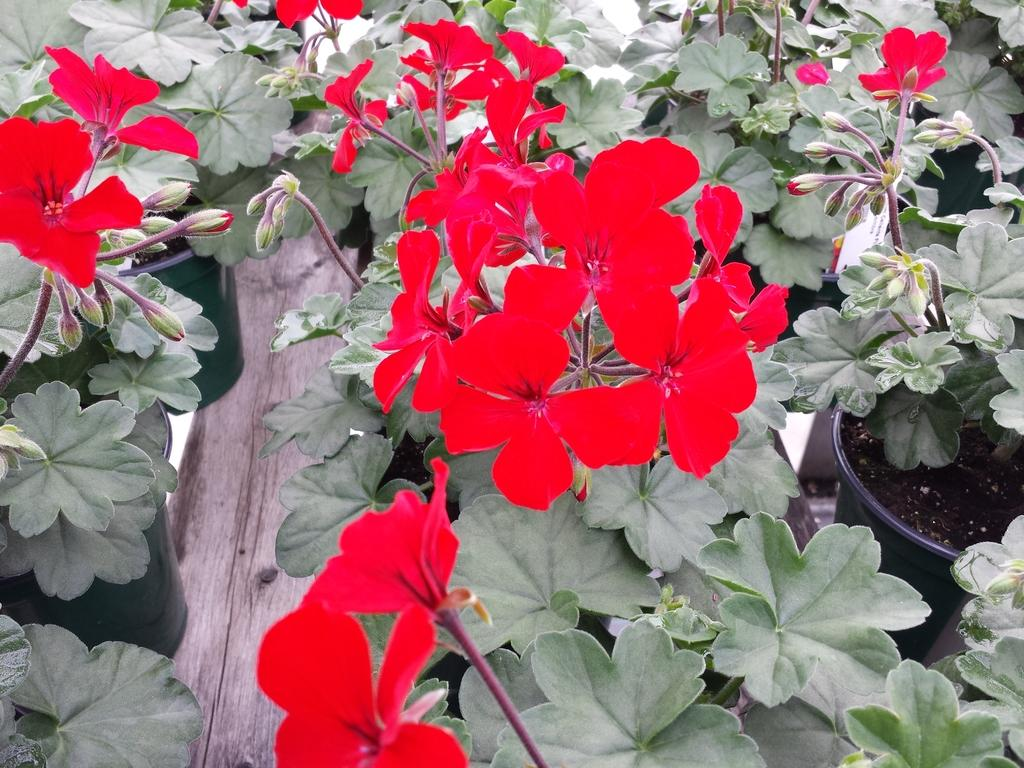What type of plants are in the image? There is a group of flowering plants in the image. How are the plants arranged in the image? The plants are in different pots. Where are the pots located in the image? The pots are placed on the floor. What language is spoken by the plants in the image? The plants in the image do not speak any language, as they are inanimate objects. 